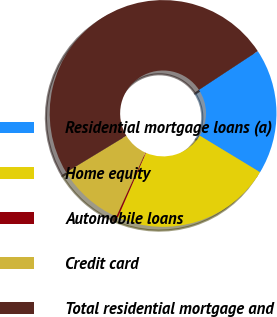<chart> <loc_0><loc_0><loc_500><loc_500><pie_chart><fcel>Residential mortgage loans (a)<fcel>Home equity<fcel>Automobile loans<fcel>Credit card<fcel>Total residential mortgage and<nl><fcel>17.94%<fcel>22.86%<fcel>0.23%<fcel>9.55%<fcel>49.41%<nl></chart> 